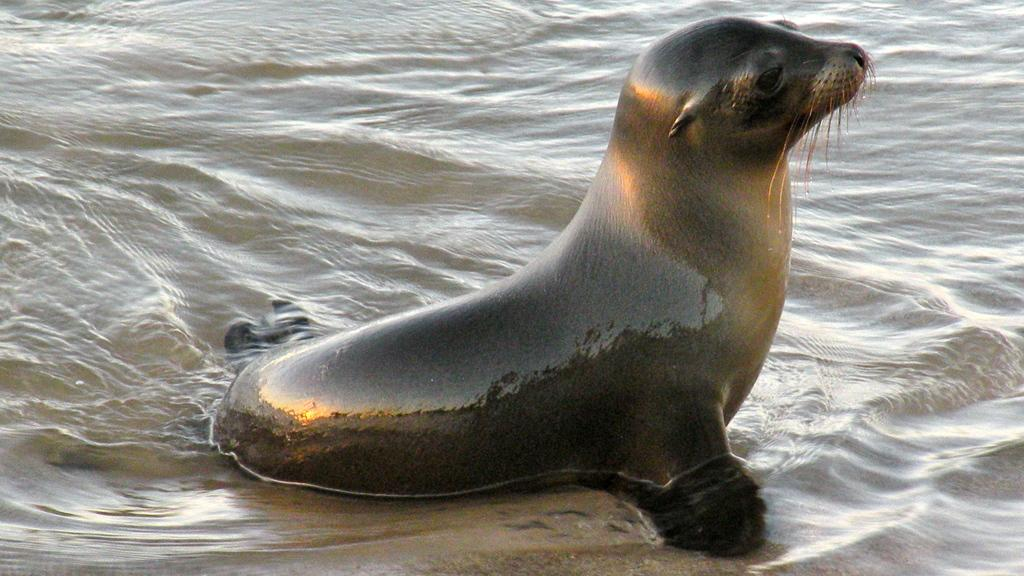What animal is present in the image? There is a seal in the image. What color is the seal? The seal is black in color. What can be seen in the background of the image? There is water visible in the background of the image. What type of toys can be seen in the image? There are no toys present in the image; it features a black seal in a watery environment. What is the heart rate of the seal in the image? There is no information about the heart rate of the seal in the image, as it is a photograph and not a live recording. 